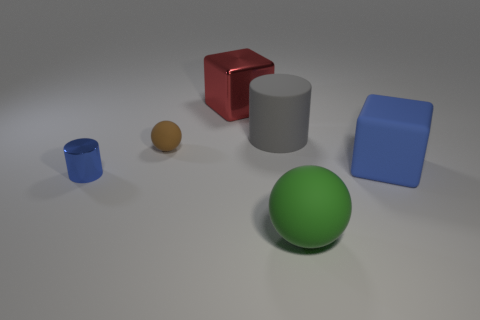How many objects are metallic blocks or small brown objects?
Offer a very short reply. 2. Do the large gray thing and the green rubber object have the same shape?
Give a very brief answer. No. Is there a green object made of the same material as the red thing?
Keep it short and to the point. No. There is a blue object that is to the left of the large green thing; are there any big green objects on the right side of it?
Keep it short and to the point. Yes. There is a rubber object on the left side of the gray object; is it the same size as the tiny blue cylinder?
Your answer should be very brief. Yes. The green object has what size?
Make the answer very short. Large. Is there another large block of the same color as the large shiny block?
Offer a terse response. No. What number of small objects are cylinders or red things?
Provide a short and direct response. 1. What size is the object that is on the left side of the large red metallic object and behind the tiny blue metal thing?
Ensure brevity in your answer.  Small. There is a large blue object; how many large metallic things are in front of it?
Offer a terse response. 0. 